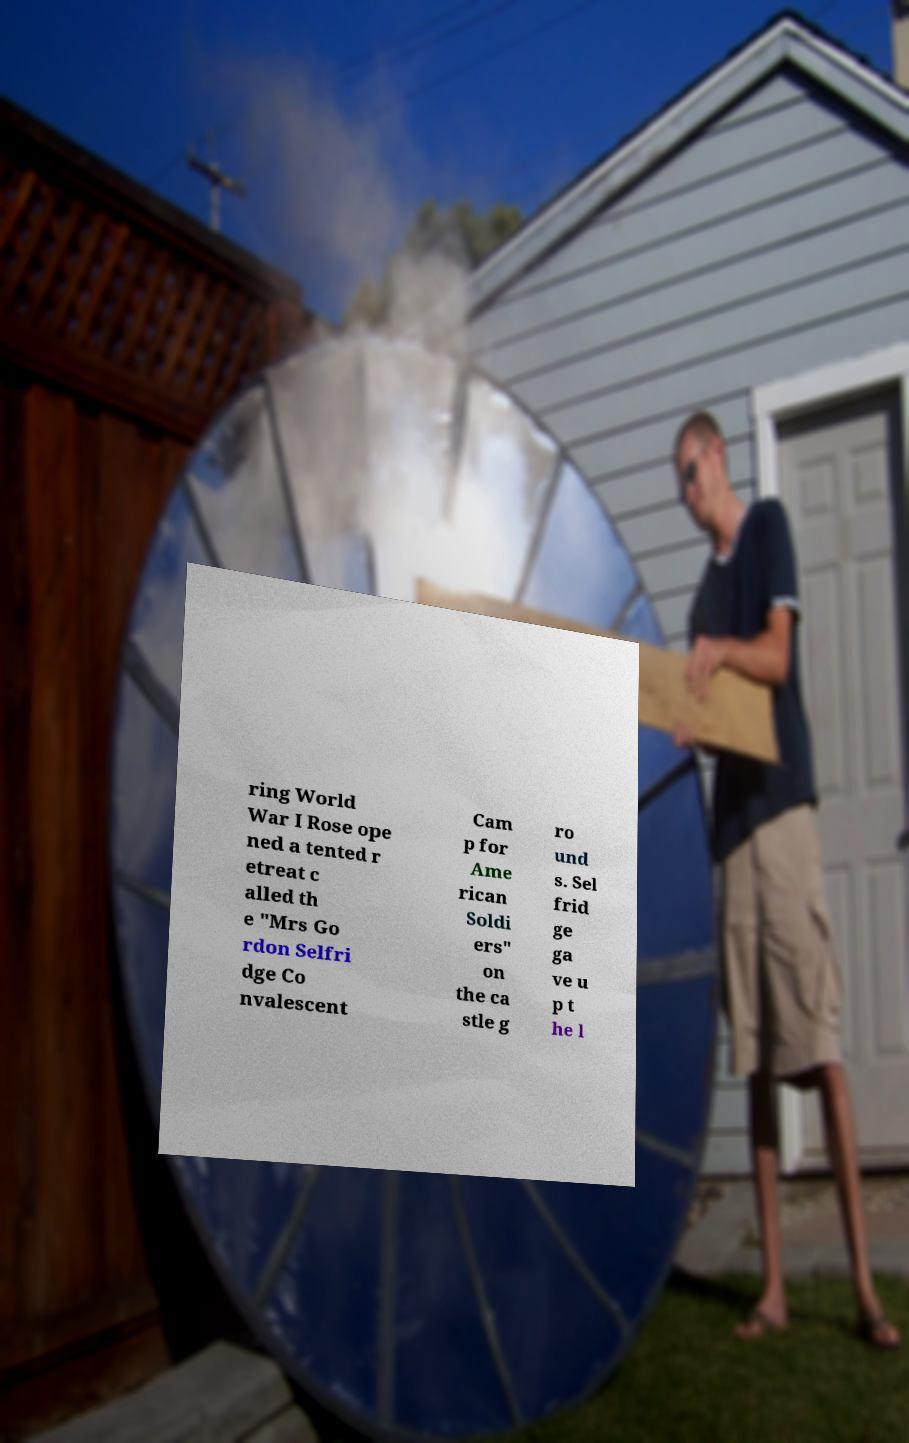Could you extract and type out the text from this image? ring World War I Rose ope ned a tented r etreat c alled th e "Mrs Go rdon Selfri dge Co nvalescent Cam p for Ame rican Soldi ers" on the ca stle g ro und s. Sel frid ge ga ve u p t he l 